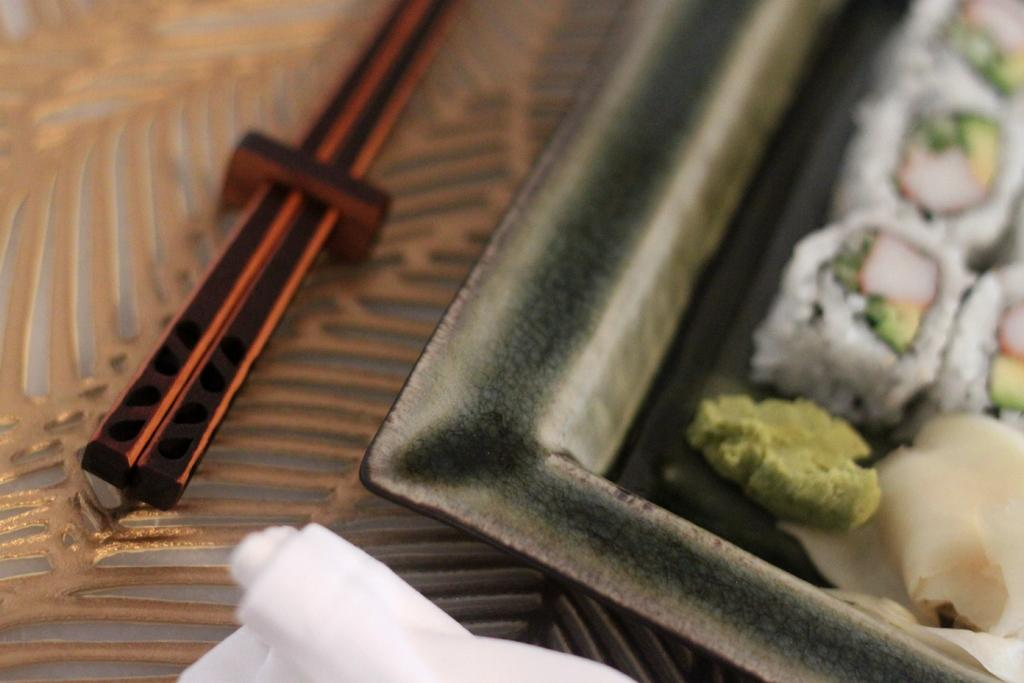What is on the plate in the image? There is food on the plate in the image. What utensils are present beside the plate? Chopsticks are present beside the plate. What is the beggar saying in the image? There is no beggar present in the image, so it is not possible to determine what they might be saying. 